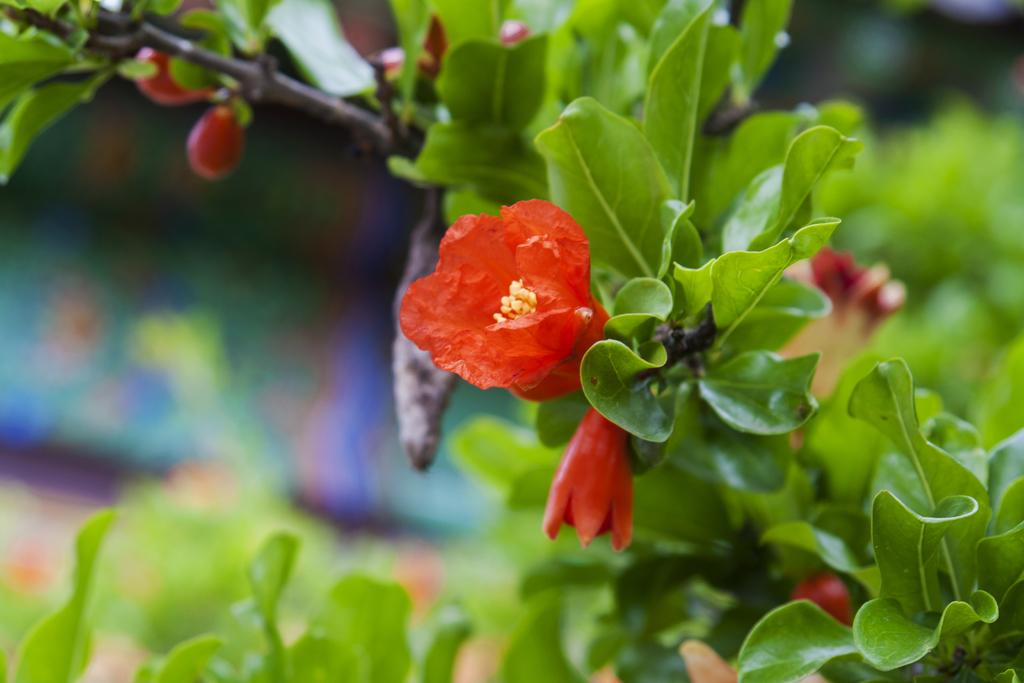What is present in the image? There is a plant in the image. What specific feature of the plant can be observed? The plant has flowers. What color are the flowers? The flowers are red in color. What else can be seen in the background of the image? There are other objects in the background of the image. How does the plant show respect to the station in the image? There is no station present in the image, and plants do not have the ability to show respect. 